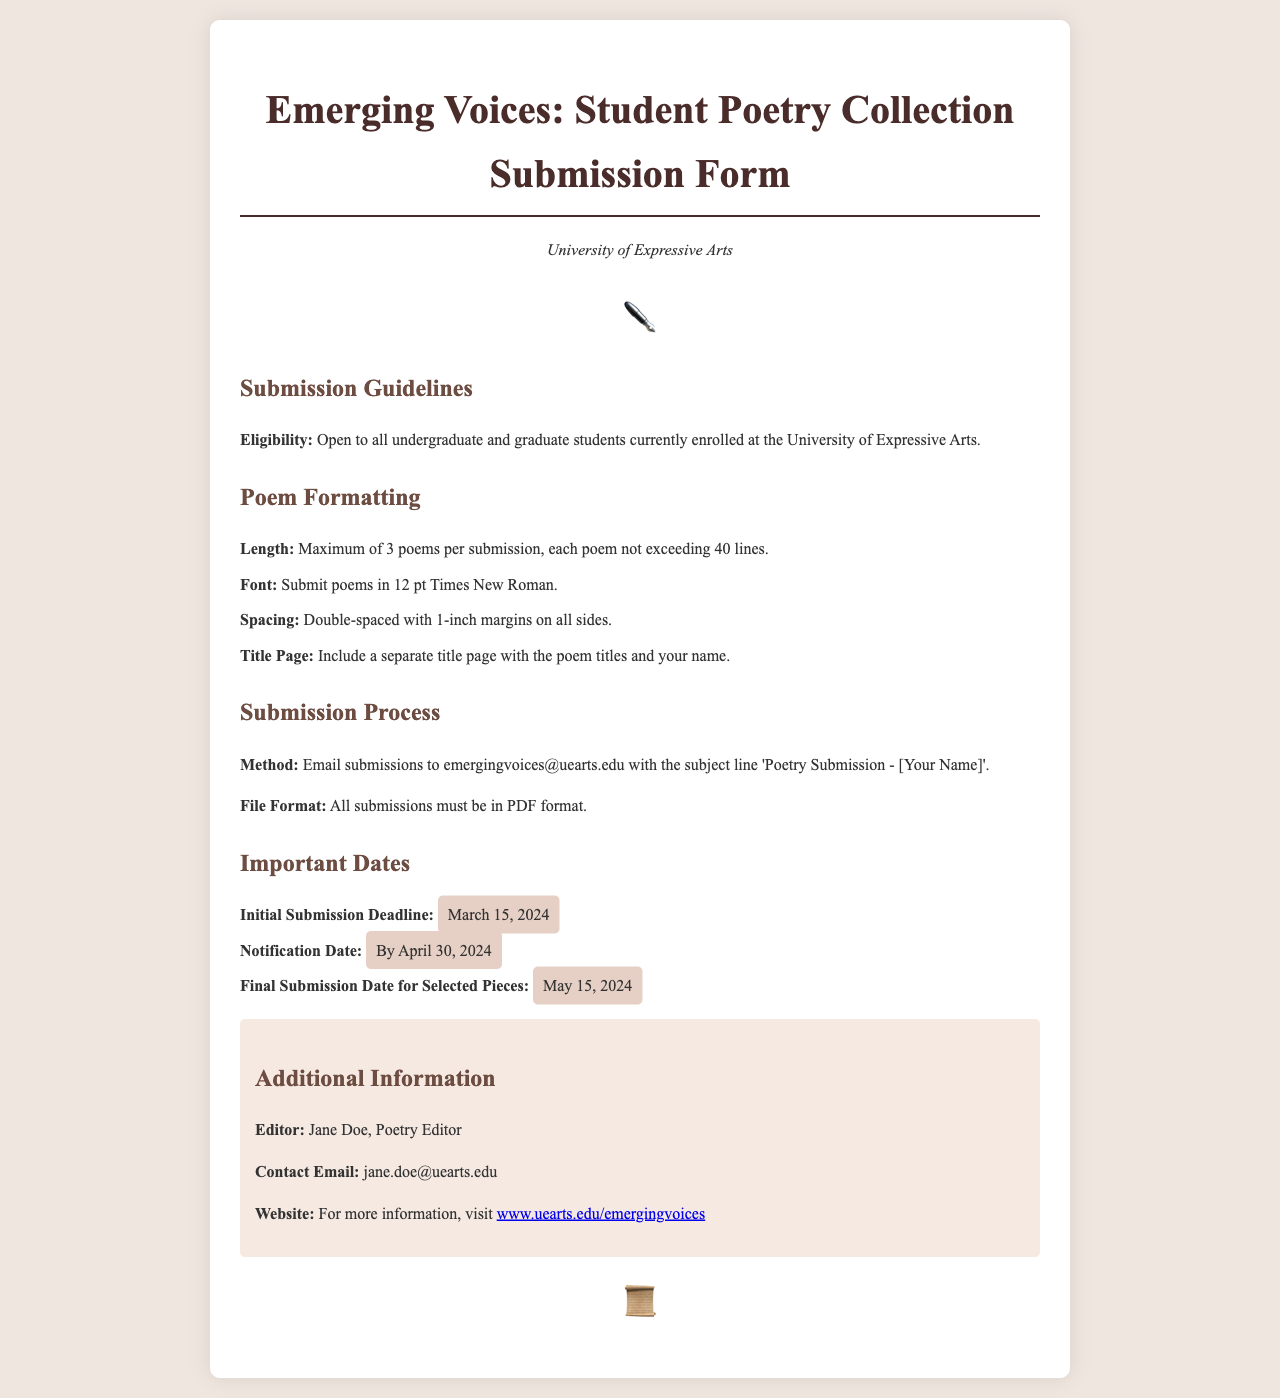What is the title of the document? The title is indicated at the top of the document and specifies the purpose, which is a submission form for poetry.
Answer: Emerging Voices: Student Poetry Collection Submission Form Who is the editor of the poetry collection? The editor is mentioned in the additional information section of the document.
Answer: Jane Doe What is the maximum number of poems allowed per submission? The guideline specifies a limit to the number of poems in a submission.
Answer: 3 poems What is the initial submission deadline? The date is provided under the important dates section, indicating the first deadline for submissions.
Answer: March 15, 2024 What is the required font size for the poems? The formatting guidelines specify the font size that should be used for submissions.
Answer: 12 pt What email should submissions be sent to? The submission process section includes the contact email for sending in the poems.
Answer: emergingvoices@uearts.edu What is the final submission date for selected pieces? The document lists this important date in the context of the selection process for contributions.
Answer: May 15, 2024 What type of document must submissions be in? This requirement is explicitly stated in the submission process section regarding the file format for submissions.
Answer: PDF format 